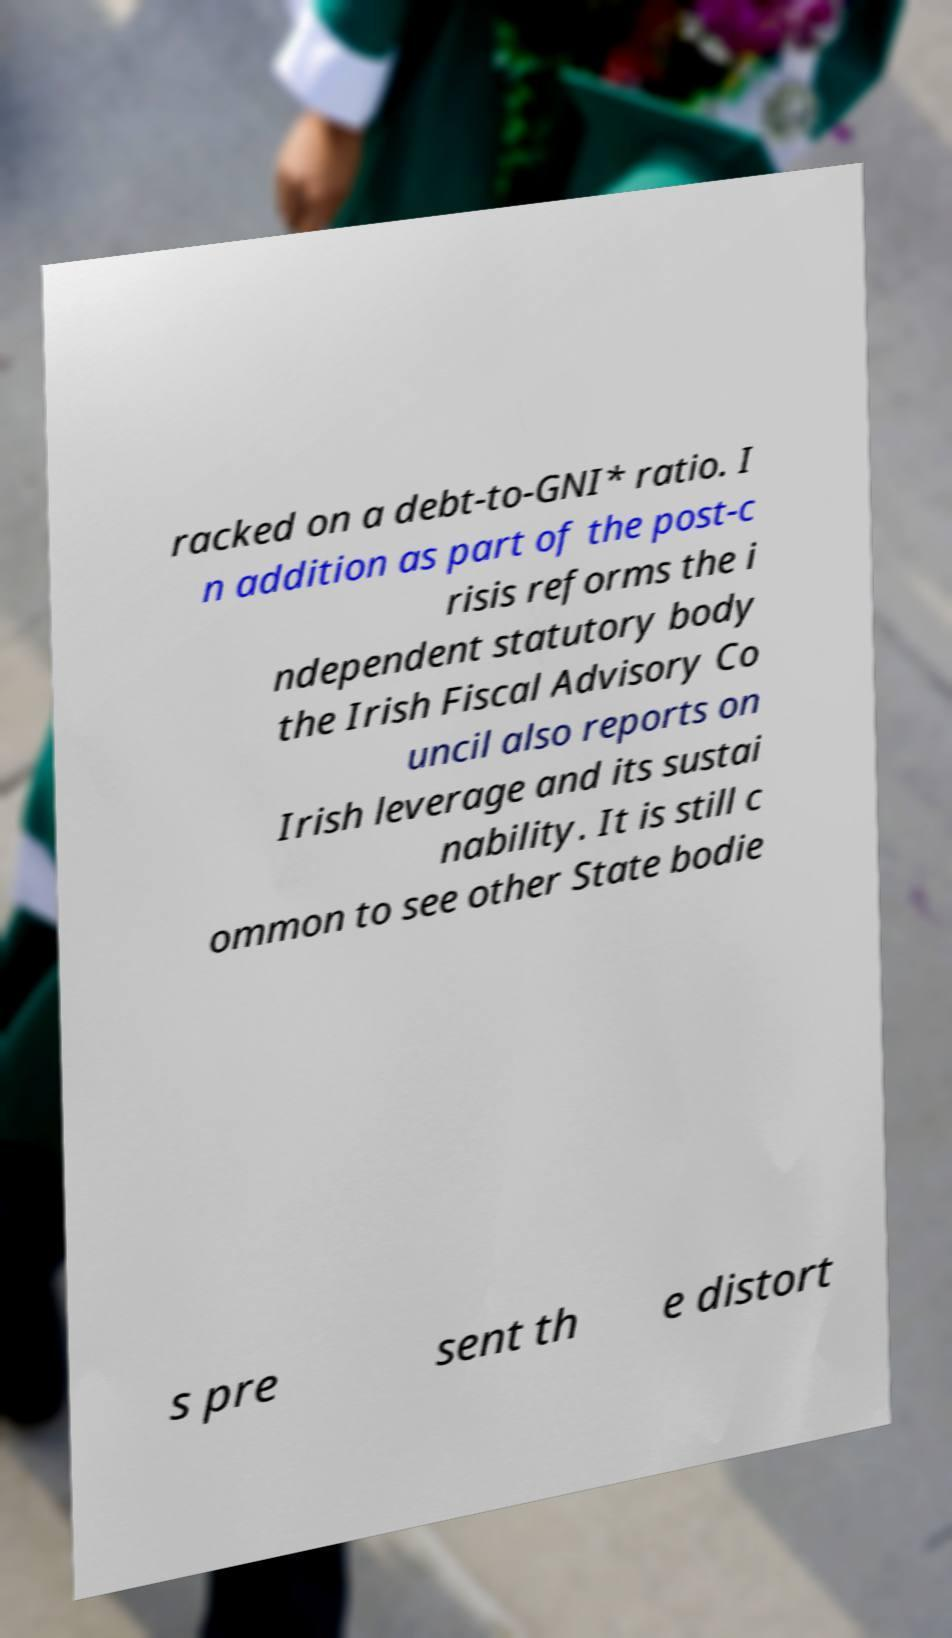For documentation purposes, I need the text within this image transcribed. Could you provide that? racked on a debt-to-GNI* ratio. I n addition as part of the post-c risis reforms the i ndependent statutory body the Irish Fiscal Advisory Co uncil also reports on Irish leverage and its sustai nability. It is still c ommon to see other State bodie s pre sent th e distort 